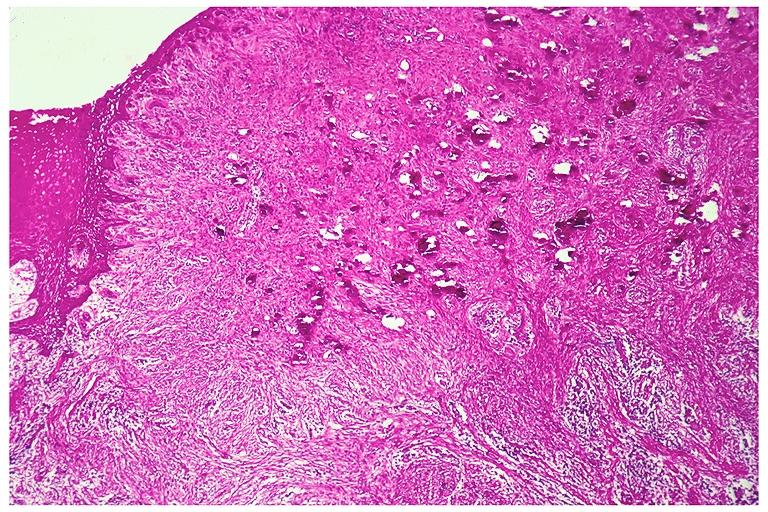s so-called median bar present?
Answer the question using a single word or phrase. No 